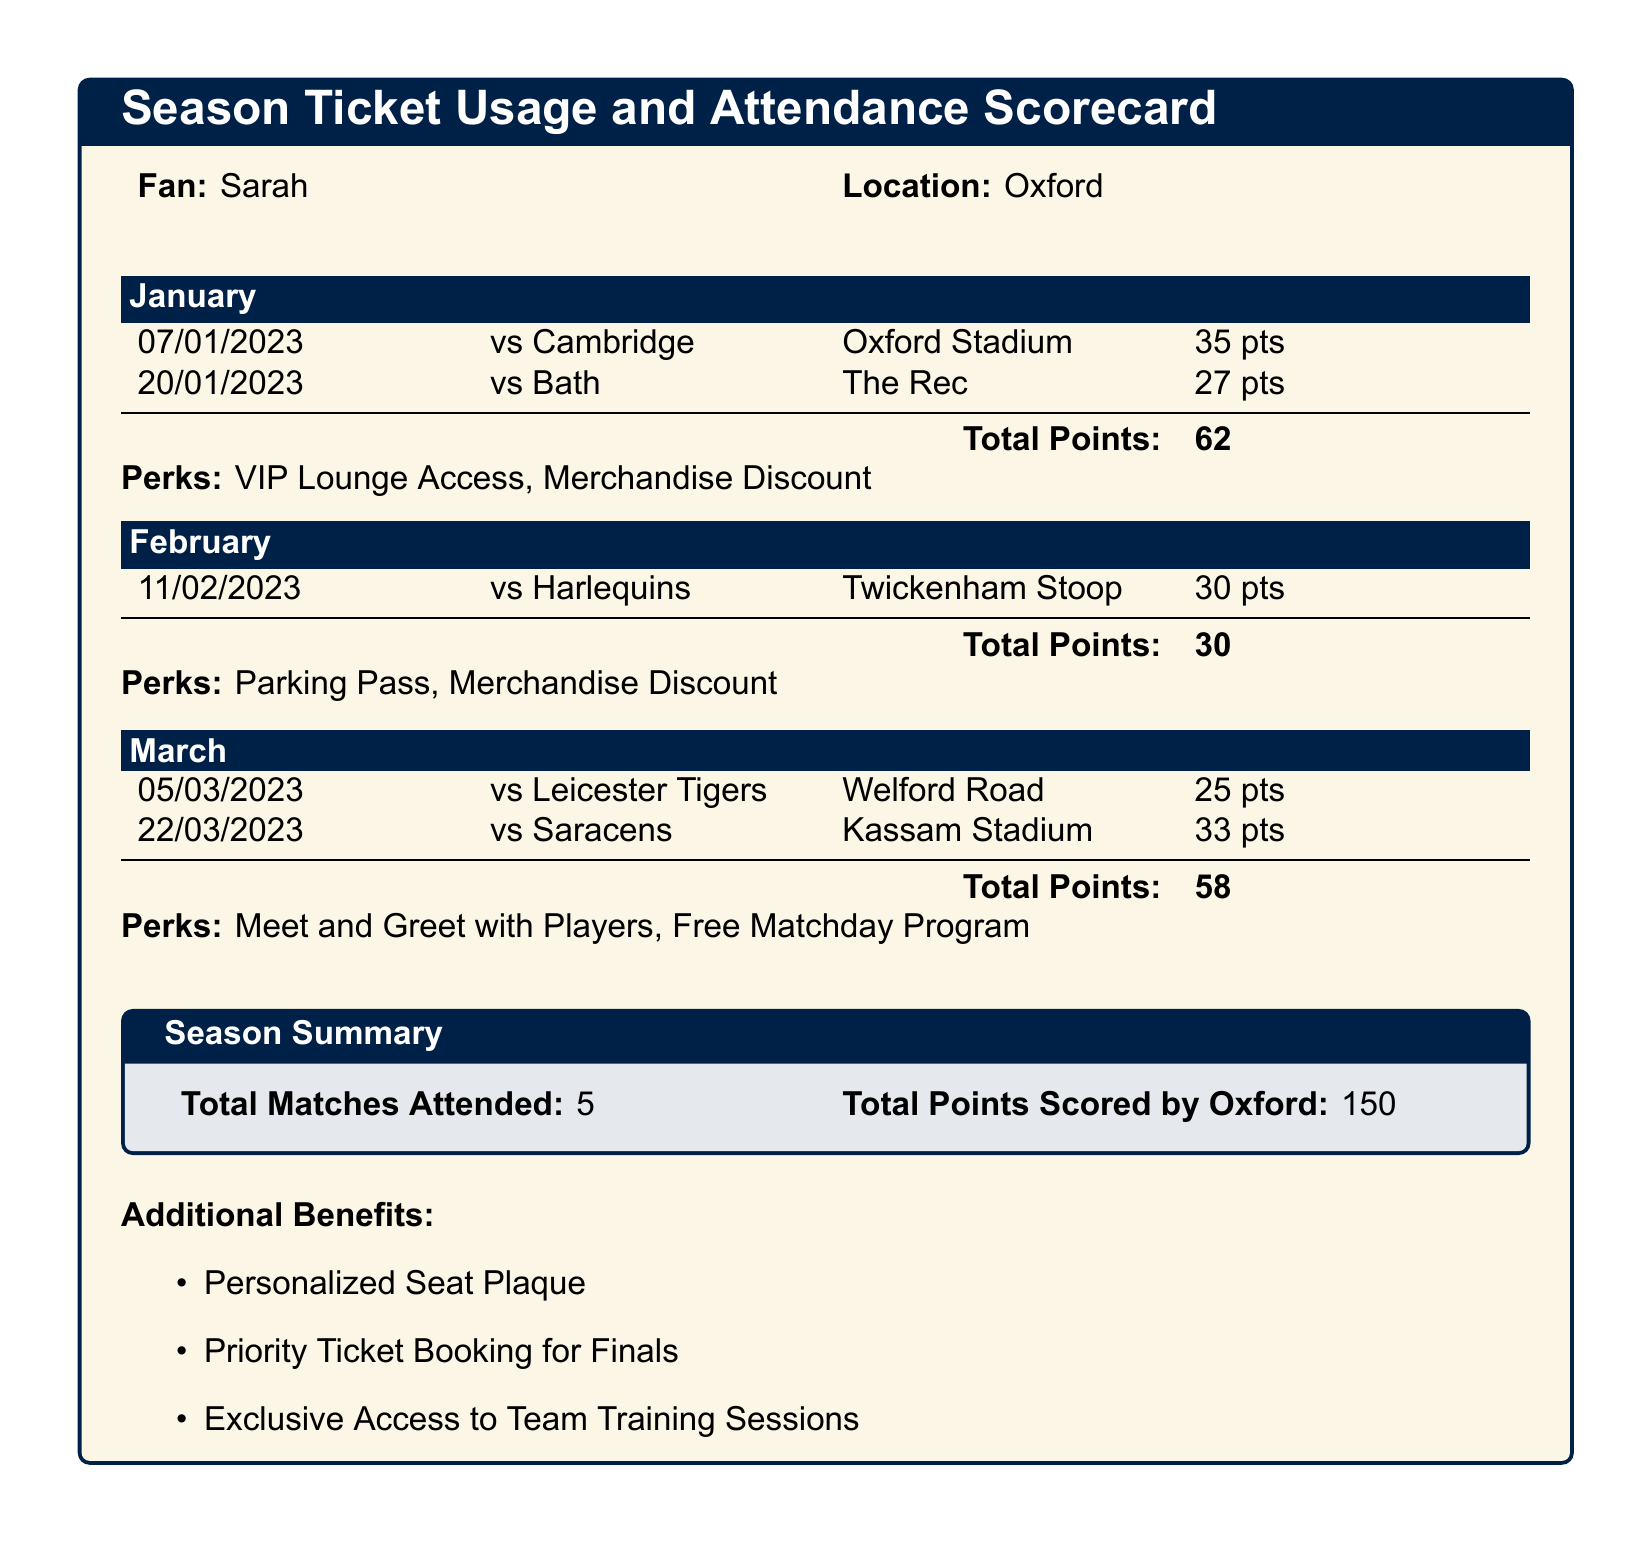What was the total points scored by Oxford in January? The total points in January can be found by adding the points from the matches attended in that month, which are 35 and 27.
Answer: 62 How many matches did Sarah attend in total? The document provides the total matches attended at the end of the season summary section.
Answer: 5 What were the total points scored by Oxford over the season? The total points scored by Oxford can be referenced from the season summary, which shows 150 points.
Answer: 150 Which match was attended on February 11, 2023? This information can be retrieved from the February section, which lists the specific match attended on that date.
Answer: vs Harlequins What perk was utilized in January? January's perks are listed in that month's section and provide specific benefits that Sarah utilized during that month.
Answer: VIP Lounge Access What is the date of the match against Saracens? The date for the Saracens match can be found in the March section under the list of attended matches.
Answer: 22/03/2023 Which venue hosted the match against Leicester Tigers? The venue for the Leicester Tigers match is specified in the March section of the document.
Answer: Welford Road What additional benefit involves a seat? The document lists various additional benefits, one of which directly mentions a seat-related perk.
Answer: Personalized Seat Plaque 